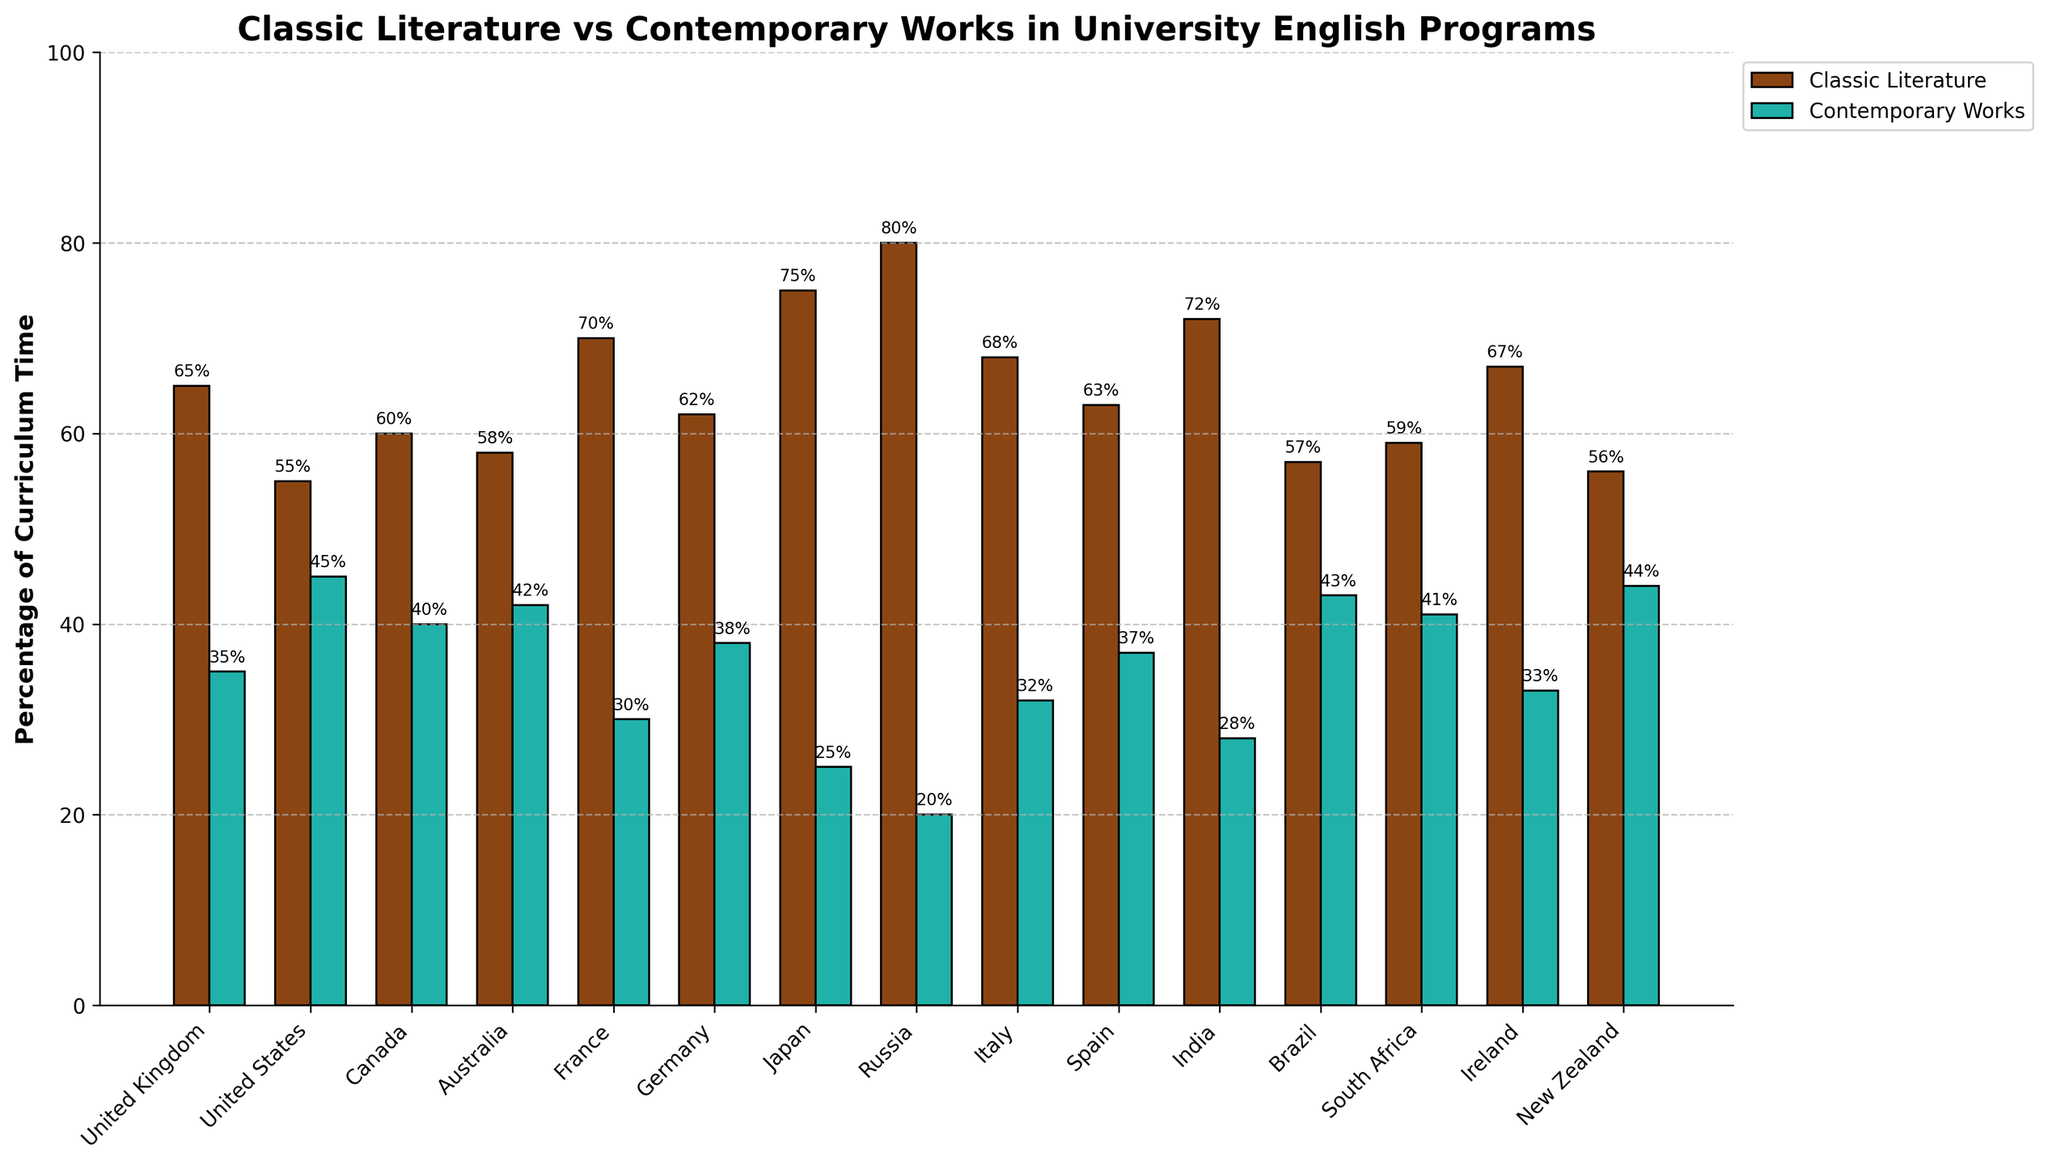Which country has the highest percentage of curriculum time dedicated to classic literature? The tallest bar in the 'Classic Literature' category indicates the highest percentage. In this case, Russia has the tallest bar for classic literature.
Answer: Russia Which country has the smallest difference between the percentages of curriculum time dedicated to classic literature and contemporary works? Calculate the differences between classic and contemporary for each country. The smallest difference is for New Zealand.
Answer: New Zealand What is the combined percentage of curriculum time dedicated to classic literature in United Kingdom and Japan? Sum the percentage values for classic literature in the United Kingdom (65%) and Japan (75%). So, 65 + 75 = 140.
Answer: 140 Which two countries have an equal percentage of curriculum time dedicated to contemporary works? Check the heights of the bars in the 'Contemporary Works' category to find two that are equal. Both United States and New Zealand have 44%.
Answer: United States, New Zealand What is the average percentage of curriculum time dedicated to classic literature across all the countries? Sum the percentages for all countries and then divide by the number of data points (15). The sum is 65+55+60+58+70+62+75+80+68+63+72+57+59+67+56 = 967. Divide by 15, so 967 / 15 = 64.47
Answer: 64.47 Which country allocates a greater percentage of its curriculum time to contemporary works than classic literature? Identify countries where the 'Contemporary Works' bar is taller than the 'Classic Literature' bar. Brazil has a greater percentage for contemporary works (43%) compared to classic literature (57%).
Answer: Brazil How much more curriculum time is dedicated to classic literature compared to contemporary works in India? Subtract the percentage for contemporary works from the classic literature percentage for India. That is, 72% - 28% = 44%.
Answer: 44 Is there any country where both curriculum time percentages add up to less than 100%? All the bar heights of classic and contemporary categories in each country add up to 100%, ensuring no country falls under this category.
Answer: No What is the difference in curriculum time percentages dedicated to classic literature between France and Italy? Subtract the percentage for Italy from France's percentage for classic literature. That is, 70% - 68% = 2%.
Answer: 2 